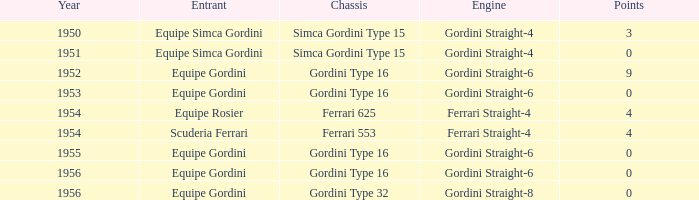How many points after 1956? 0.0. 